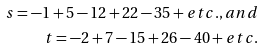<formula> <loc_0><loc_0><loc_500><loc_500>s = - 1 + 5 - 1 2 + 2 2 - 3 5 + e t c . , a n d \\ t = - 2 + 7 - 1 5 + 2 6 - 4 0 + e t c .</formula> 